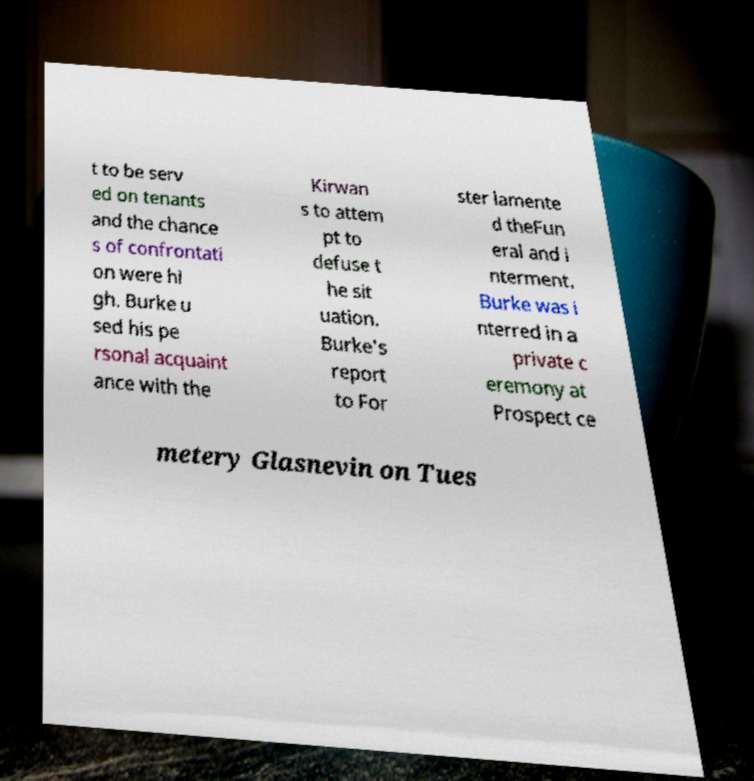There's text embedded in this image that I need extracted. Can you transcribe it verbatim? t to be serv ed on tenants and the chance s of confrontati on were hi gh. Burke u sed his pe rsonal acquaint ance with the Kirwan s to attem pt to defuse t he sit uation. Burke's report to For ster lamente d theFun eral and i nterment. Burke was i nterred in a private c eremony at Prospect ce metery Glasnevin on Tues 